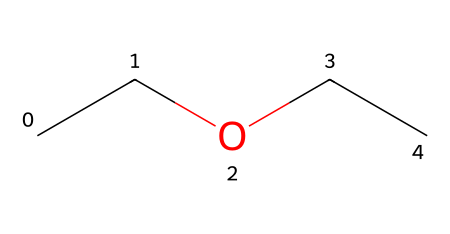What is the name of this chemical? The SMILES representation "CCOCC" indicates that the molecule consists of two ethyl groups (CC) connected by an ether bond (O). Thus, it is commonly known as diethyl ether.
Answer: diethyl ether How many carbon atoms are in this chemical? Analyzing the SMILES "CCOCC," we can count the carbon atoms: there are four total (two from each ethyl group).
Answer: four What type of chemical bond connects the carbon atoms to the oxygen? In diethyl ether, the carbon atoms are connected to the oxygen atom via single covalent bonds, typical of ether structures.
Answer: single covalent What is the total number of hydrogen atoms in this compound? Each ethyl group (CC) contributes five hydrogen atoms (C2H5), and since there are two ethyl groups, the total number is 10. The oxygen atom does not contribute any hydrogens, so 10 is the final count.
Answer: ten Why does diethyl ether have a low boiling point compared to alcohols? Diethyl ether lacks the hydroxyl group (-OH) present in alcohols, leading to weaker van der Waals forces instead of stronger hydrogen bonding. This results in a lower boiling point for diethyl ether than corresponding alcohols.
Answer: weaker van der Waals forces How many ether functional groups are present in this molecule? The presence of the single "O" in the SMILES representation indicates there is one ether functional group in diethyl ether. Therefore, there is a single ether in the compound.
Answer: one 